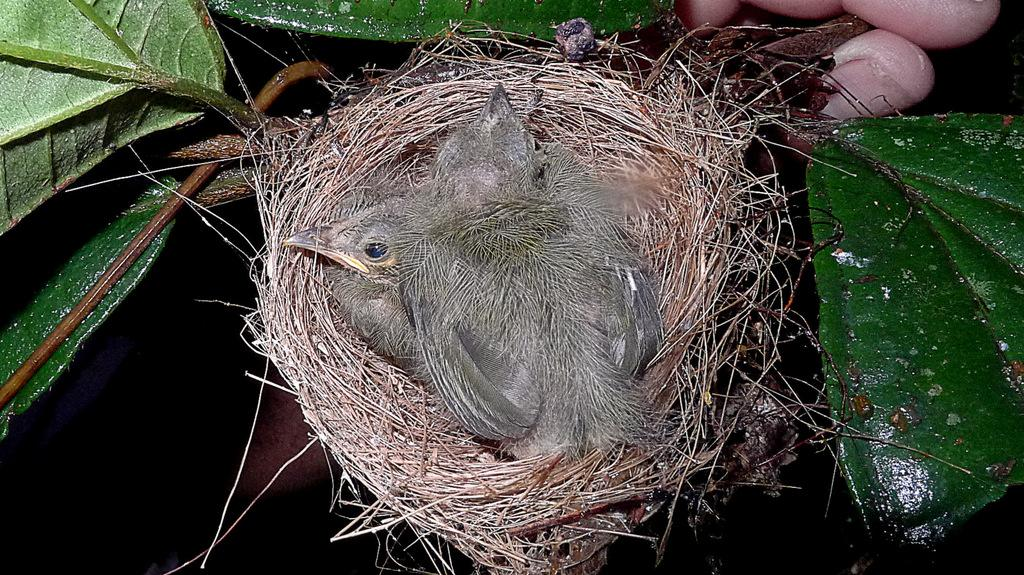What is the person's finger holding in the image? There is a person's finger holding a nest in the image. What can be found inside the nest? There is a bird in the nest. What is surrounding the nest in the image? There are leaves around the nest. What type of gun is being used to carry the nest in the image? There is no gun present in the image; a person's finger is holding the nest. 